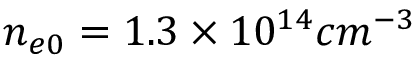<formula> <loc_0><loc_0><loc_500><loc_500>n _ { e 0 } = 1 . 3 \times 1 0 ^ { 1 4 } c m ^ { - 3 }</formula> 